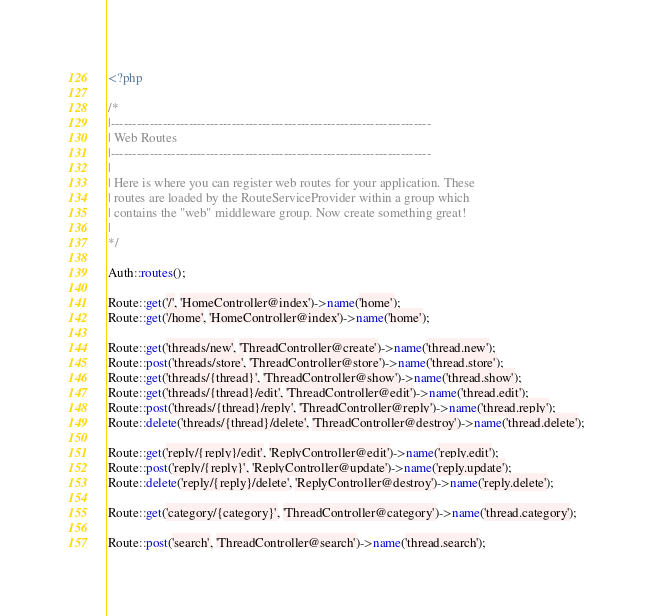<code> <loc_0><loc_0><loc_500><loc_500><_PHP_><?php

/*
|--------------------------------------------------------------------------
| Web Routes
|--------------------------------------------------------------------------
|
| Here is where you can register web routes for your application. These
| routes are loaded by the RouteServiceProvider within a group which
| contains the "web" middleware group. Now create something great!
|
*/

Auth::routes();

Route::get('/', 'HomeController@index')->name('home');
Route::get('/home', 'HomeController@index')->name('home');

Route::get('threads/new', 'ThreadController@create')->name('thread.new');
Route::post('threads/store', 'ThreadController@store')->name('thread.store');
Route::get('threads/{thread}', 'ThreadController@show')->name('thread.show');
Route::get('threads/{thread}/edit', 'ThreadController@edit')->name('thread.edit');
Route::post('threads/{thread}/reply', 'ThreadController@reply')->name('thread.reply');
Route::delete('threads/{thread}/delete', 'ThreadController@destroy')->name('thread.delete');

Route::get('reply/{reply}/edit', 'ReplyController@edit')->name('reply.edit');
Route::post('reply/{reply}', 'ReplyController@update')->name('reply.update');
Route::delete('reply/{reply}/delete', 'ReplyController@destroy')->name('reply.delete');

Route::get('category/{category}', 'ThreadController@category')->name('thread.category');

Route::post('search', 'ThreadController@search')->name('thread.search');

</code> 